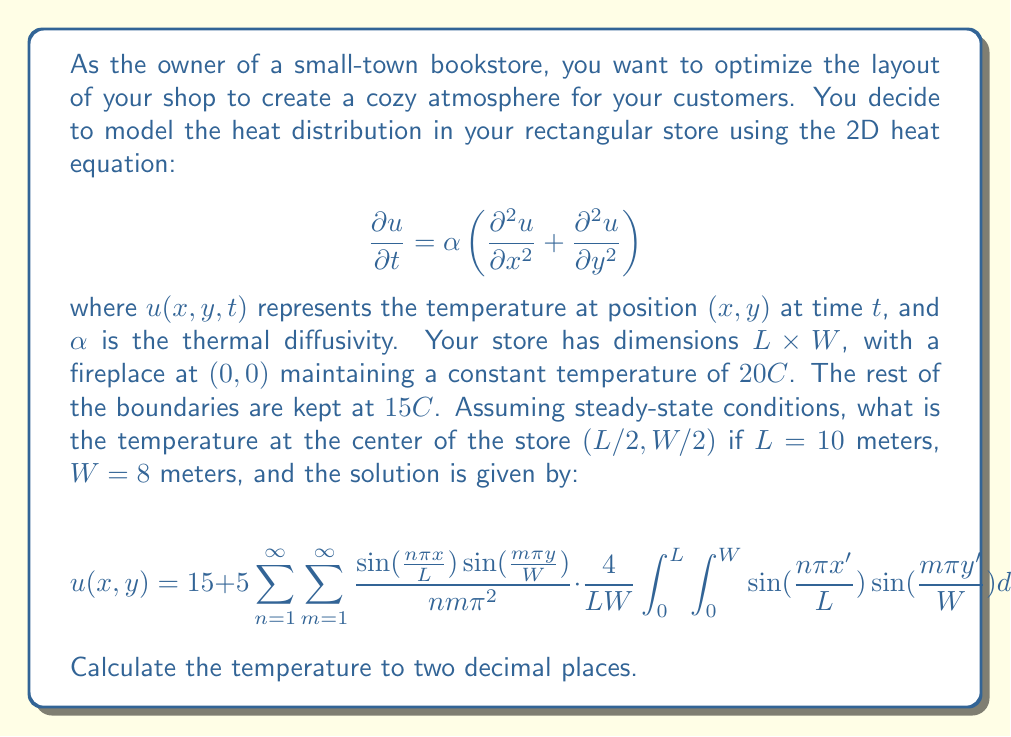Solve this math problem. To solve this problem, we need to follow these steps:

1) First, we recognize that the given solution is in the form of a double Fourier series for the steady-state heat equation. The boundary conditions are incorporated into this solution.

2) We need to evaluate the double integral inside the summation:

   $$\frac{4}{LW} \int_0^L \int_0^W \sin(\frac{n\pi x'}{L}) \sin(\frac{m\pi y'}{W}) dx' dy'$$

   This integral equals 0 for all $n$ and $m$ except when $n = m = 1$. In this case, it equals 1.

3) Therefore, our solution simplifies to:

   $$u(x,y) = 15 + \frac{20}{\pi^2} \sin(\frac{\pi x}{L}) \sin(\frac{\pi y}{W})$$

4) We want to find the temperature at the center of the store, so we need to evaluate $u(L/2, W/2)$:

   $$u(L/2, W/2) = 15 + \frac{20}{\pi^2} \sin(\frac{\pi}{2}) \sin(\frac{\pi}{2})$$

5) We know that $\sin(\frac{\pi}{2}) = 1$, so:

   $$u(L/2, W/2) = 15 + \frac{20}{\pi^2}$$

6) Calculate the final result:
   
   $$u(L/2, W/2) = 15 + \frac{20}{\pi^2} \approx 17.03°C$$

Thus, the temperature at the center of the store is approximately 17.03°C.
Answer: 17.03°C 